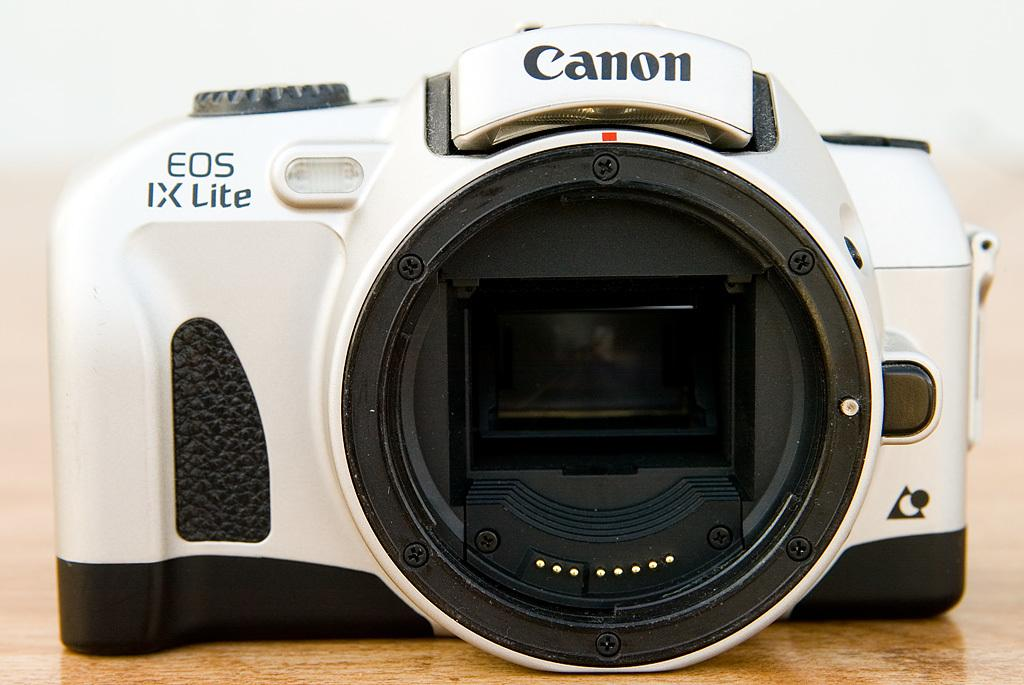Provide a one-sentence caption for the provided image. A white Canon camera with no lens on. 